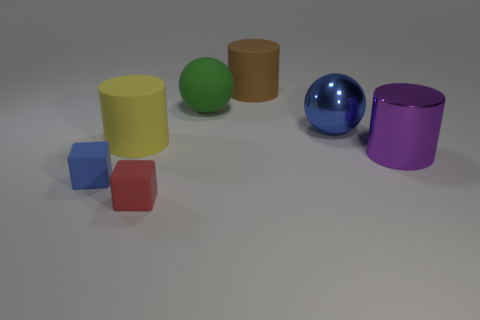Subtract all large rubber cylinders. How many cylinders are left? 1 Add 1 blue shiny balls. How many objects exist? 8 Subtract all yellow cylinders. How many cylinders are left? 2 Subtract all blocks. How many objects are left? 5 Subtract 0 gray blocks. How many objects are left? 7 Subtract all yellow cylinders. Subtract all green cubes. How many cylinders are left? 2 Subtract all purple metallic cylinders. Subtract all matte objects. How many objects are left? 1 Add 3 blue shiny objects. How many blue shiny objects are left? 4 Add 5 small red rubber things. How many small red rubber things exist? 6 